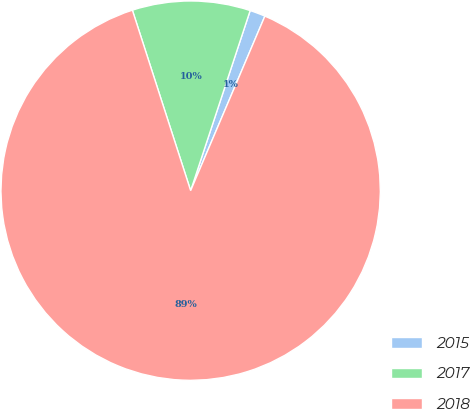Convert chart to OTSL. <chart><loc_0><loc_0><loc_500><loc_500><pie_chart><fcel>2015<fcel>2017<fcel>2018<nl><fcel>1.32%<fcel>10.05%<fcel>88.62%<nl></chart> 